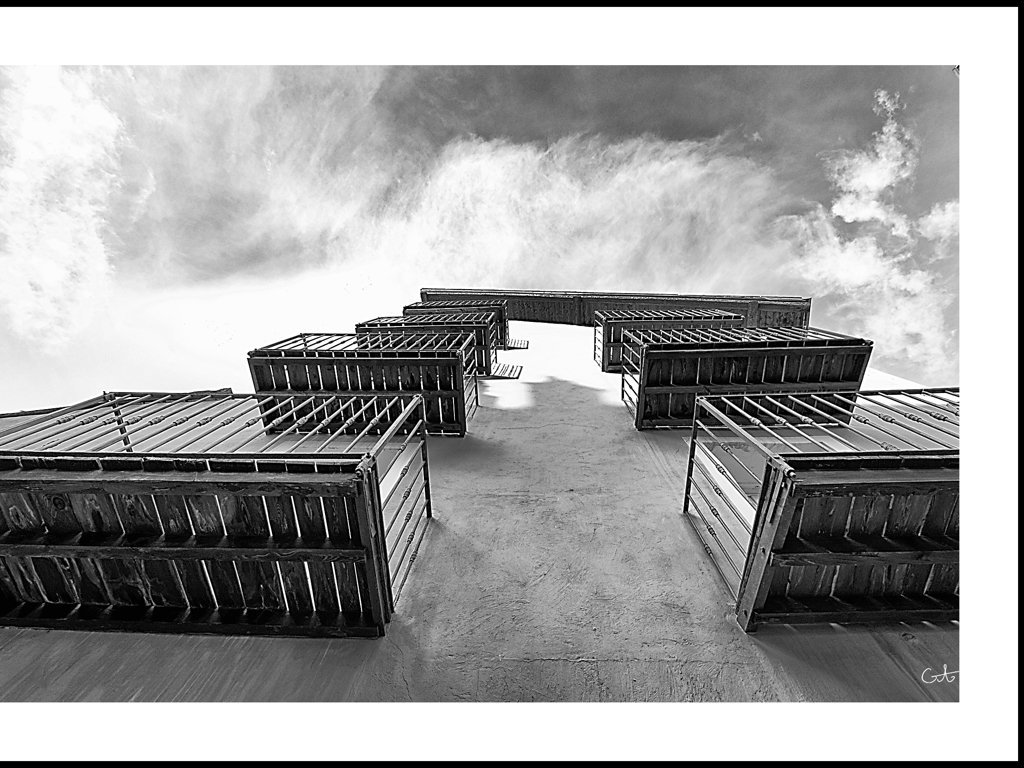What mood does this image evoke? The stark contrast between the well-defined structure and the fluid, organic forms of the clouds instills a mood of contemplation and awe. Black-and-white processing further intensifies the mood, giving the image a timeless quality and allowing for a nuanced interplay between light and shadow. 